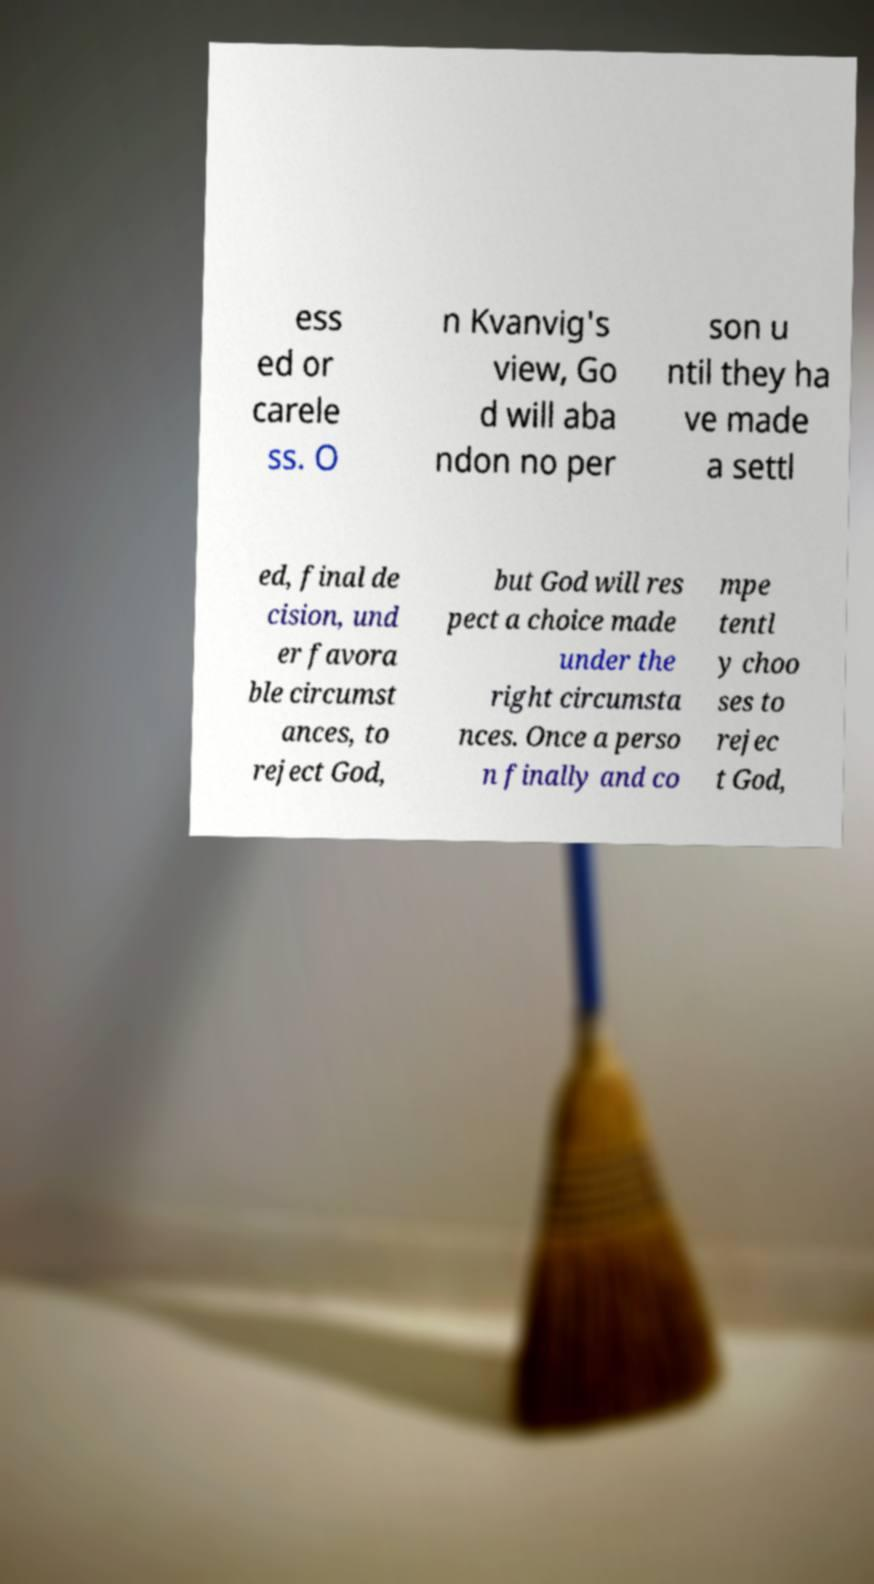Can you accurately transcribe the text from the provided image for me? ess ed or carele ss. O n Kvanvig's view, Go d will aba ndon no per son u ntil they ha ve made a settl ed, final de cision, und er favora ble circumst ances, to reject God, but God will res pect a choice made under the right circumsta nces. Once a perso n finally and co mpe tentl y choo ses to rejec t God, 